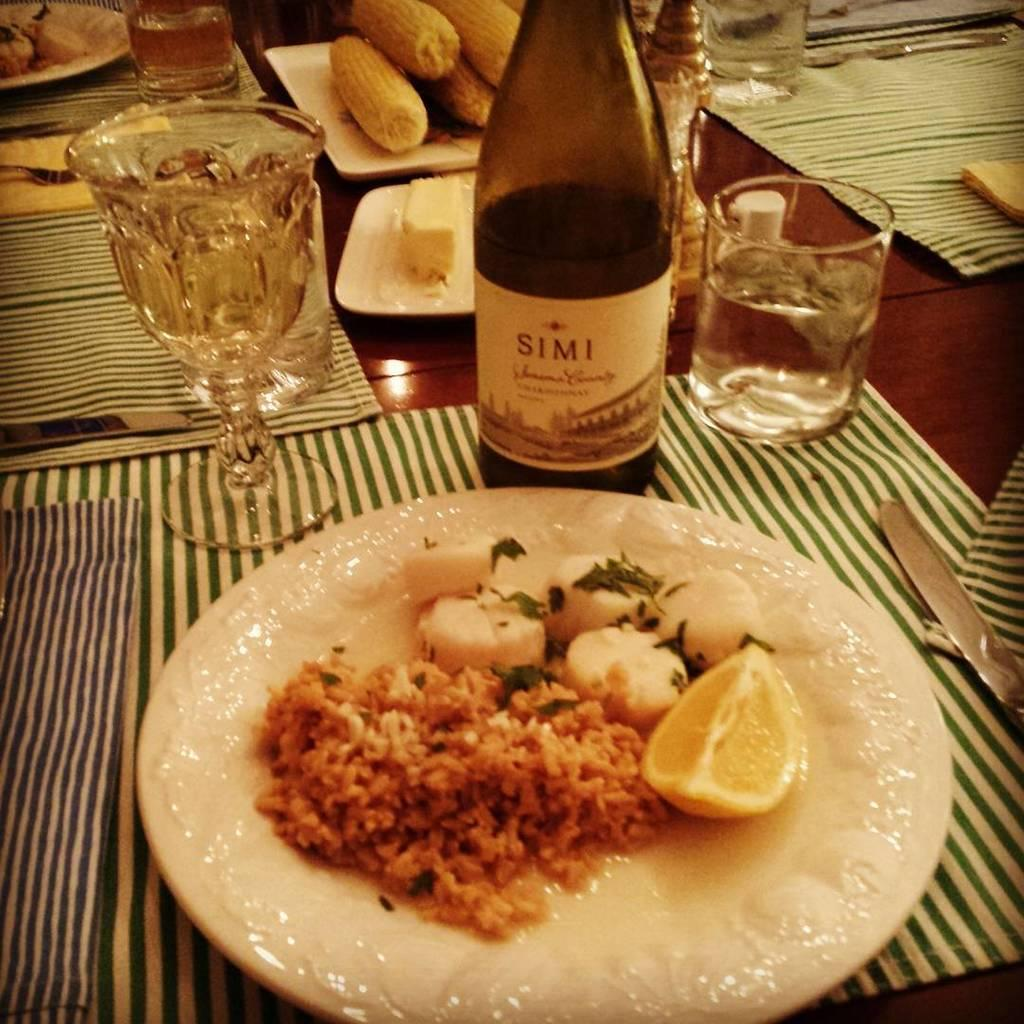Provide a one-sentence caption for the provided image. A formal dinner plate of food of scallops and rice with a bottle of wine From Simi winery. 